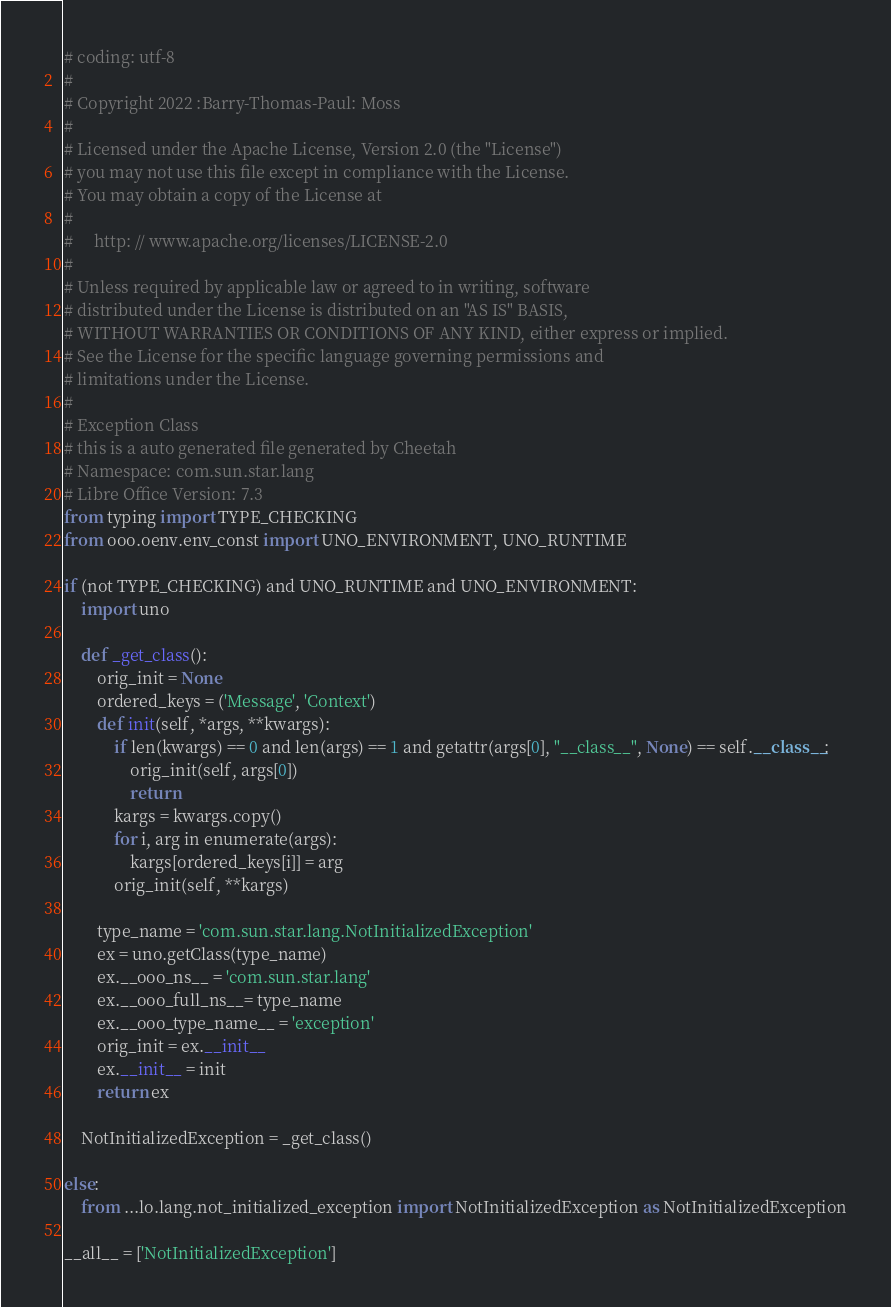Convert code to text. <code><loc_0><loc_0><loc_500><loc_500><_Python_># coding: utf-8
#
# Copyright 2022 :Barry-Thomas-Paul: Moss
#
# Licensed under the Apache License, Version 2.0 (the "License")
# you may not use this file except in compliance with the License.
# You may obtain a copy of the License at
#
#     http: // www.apache.org/licenses/LICENSE-2.0
#
# Unless required by applicable law or agreed to in writing, software
# distributed under the License is distributed on an "AS IS" BASIS,
# WITHOUT WARRANTIES OR CONDITIONS OF ANY KIND, either express or implied.
# See the License for the specific language governing permissions and
# limitations under the License.
#
# Exception Class
# this is a auto generated file generated by Cheetah
# Namespace: com.sun.star.lang
# Libre Office Version: 7.3
from typing import TYPE_CHECKING
from ooo.oenv.env_const import UNO_ENVIRONMENT, UNO_RUNTIME

if (not TYPE_CHECKING) and UNO_RUNTIME and UNO_ENVIRONMENT:
    import uno

    def _get_class():
        orig_init = None
        ordered_keys = ('Message', 'Context')
        def init(self, *args, **kwargs):
            if len(kwargs) == 0 and len(args) == 1 and getattr(args[0], "__class__", None) == self.__class__:
                orig_init(self, args[0])
                return
            kargs = kwargs.copy()
            for i, arg in enumerate(args):
                kargs[ordered_keys[i]] = arg
            orig_init(self, **kargs)

        type_name = 'com.sun.star.lang.NotInitializedException'
        ex = uno.getClass(type_name)
        ex.__ooo_ns__ = 'com.sun.star.lang'
        ex.__ooo_full_ns__= type_name
        ex.__ooo_type_name__ = 'exception'
        orig_init = ex.__init__
        ex.__init__ = init
        return ex

    NotInitializedException = _get_class()

else:
    from ...lo.lang.not_initialized_exception import NotInitializedException as NotInitializedException

__all__ = ['NotInitializedException']

</code> 